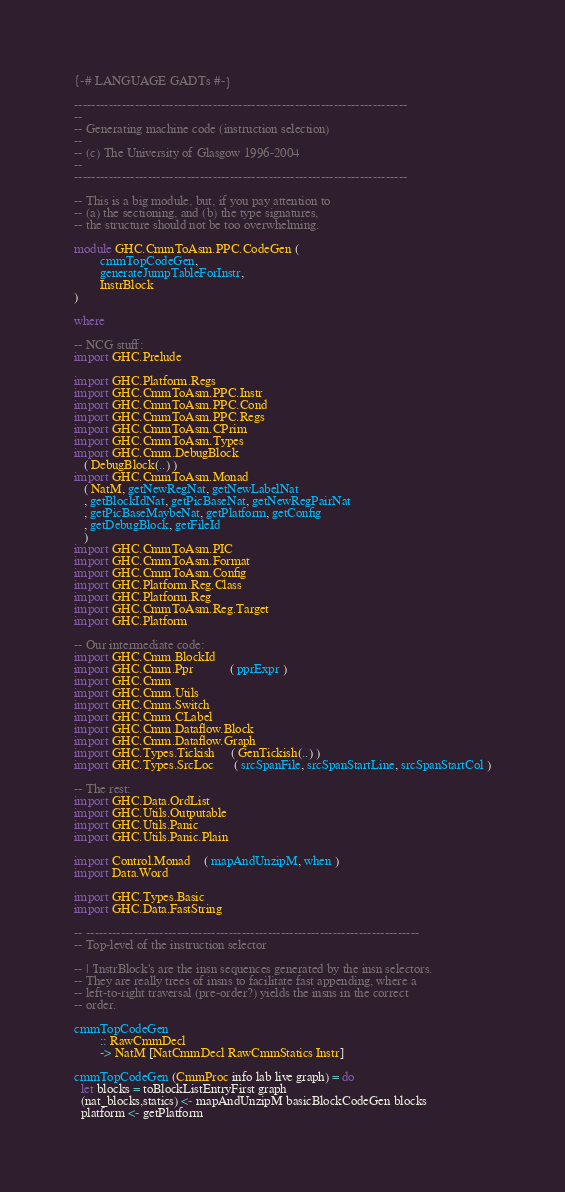Convert code to text. <code><loc_0><loc_0><loc_500><loc_500><_Haskell_>{-# LANGUAGE GADTs #-}

-----------------------------------------------------------------------------
--
-- Generating machine code (instruction selection)
--
-- (c) The University of Glasgow 1996-2004
--
-----------------------------------------------------------------------------

-- This is a big module, but, if you pay attention to
-- (a) the sectioning, and (b) the type signatures,
-- the structure should not be too overwhelming.

module GHC.CmmToAsm.PPC.CodeGen (
        cmmTopCodeGen,
        generateJumpTableForInstr,
        InstrBlock
)

where

-- NCG stuff:
import GHC.Prelude

import GHC.Platform.Regs
import GHC.CmmToAsm.PPC.Instr
import GHC.CmmToAsm.PPC.Cond
import GHC.CmmToAsm.PPC.Regs
import GHC.CmmToAsm.CPrim
import GHC.CmmToAsm.Types
import GHC.Cmm.DebugBlock
   ( DebugBlock(..) )
import GHC.CmmToAsm.Monad
   ( NatM, getNewRegNat, getNewLabelNat
   , getBlockIdNat, getPicBaseNat, getNewRegPairNat
   , getPicBaseMaybeNat, getPlatform, getConfig
   , getDebugBlock, getFileId
   )
import GHC.CmmToAsm.PIC
import GHC.CmmToAsm.Format
import GHC.CmmToAsm.Config
import GHC.Platform.Reg.Class
import GHC.Platform.Reg
import GHC.CmmToAsm.Reg.Target
import GHC.Platform

-- Our intermediate code:
import GHC.Cmm.BlockId
import GHC.Cmm.Ppr           ( pprExpr )
import GHC.Cmm
import GHC.Cmm.Utils
import GHC.Cmm.Switch
import GHC.Cmm.CLabel
import GHC.Cmm.Dataflow.Block
import GHC.Cmm.Dataflow.Graph
import GHC.Types.Tickish     ( GenTickish(..) )
import GHC.Types.SrcLoc      ( srcSpanFile, srcSpanStartLine, srcSpanStartCol )

-- The rest:
import GHC.Data.OrdList
import GHC.Utils.Outputable
import GHC.Utils.Panic
import GHC.Utils.Panic.Plain

import Control.Monad    ( mapAndUnzipM, when )
import Data.Word

import GHC.Types.Basic
import GHC.Data.FastString

-- -----------------------------------------------------------------------------
-- Top-level of the instruction selector

-- | 'InstrBlock's are the insn sequences generated by the insn selectors.
-- They are really trees of insns to facilitate fast appending, where a
-- left-to-right traversal (pre-order?) yields the insns in the correct
-- order.

cmmTopCodeGen
        :: RawCmmDecl
        -> NatM [NatCmmDecl RawCmmStatics Instr]

cmmTopCodeGen (CmmProc info lab live graph) = do
  let blocks = toBlockListEntryFirst graph
  (nat_blocks,statics) <- mapAndUnzipM basicBlockCodeGen blocks
  platform <- getPlatform</code> 